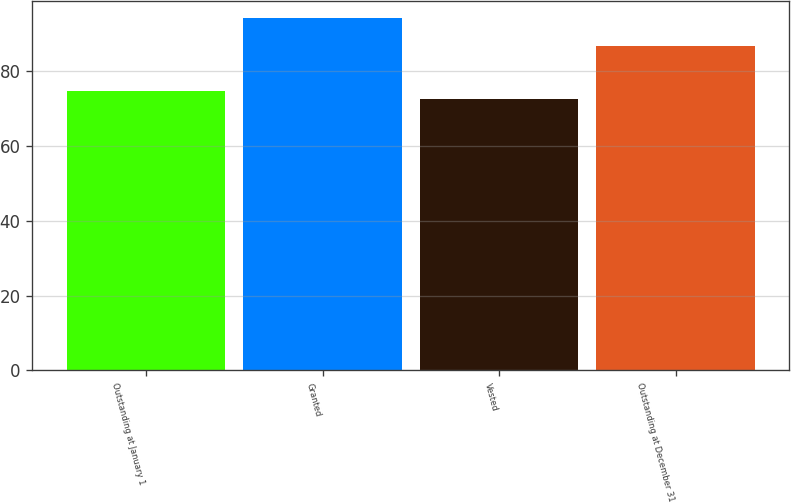<chart> <loc_0><loc_0><loc_500><loc_500><bar_chart><fcel>Outstanding at January 1<fcel>Granted<fcel>Vested<fcel>Outstanding at December 31<nl><fcel>74.62<fcel>94.11<fcel>72.46<fcel>86.6<nl></chart> 